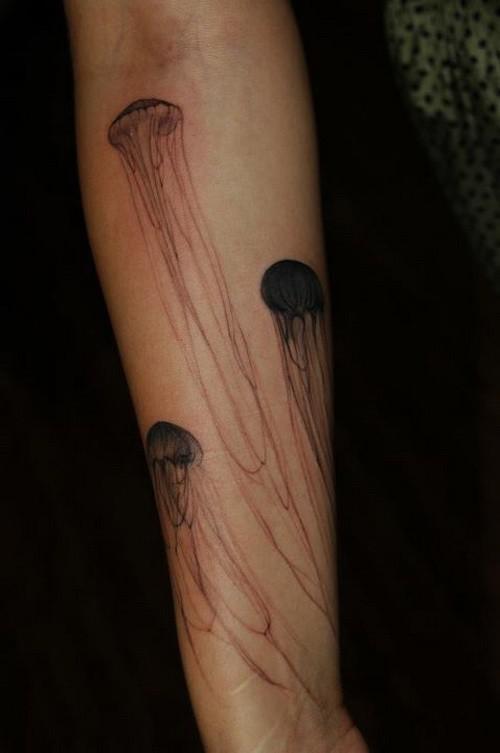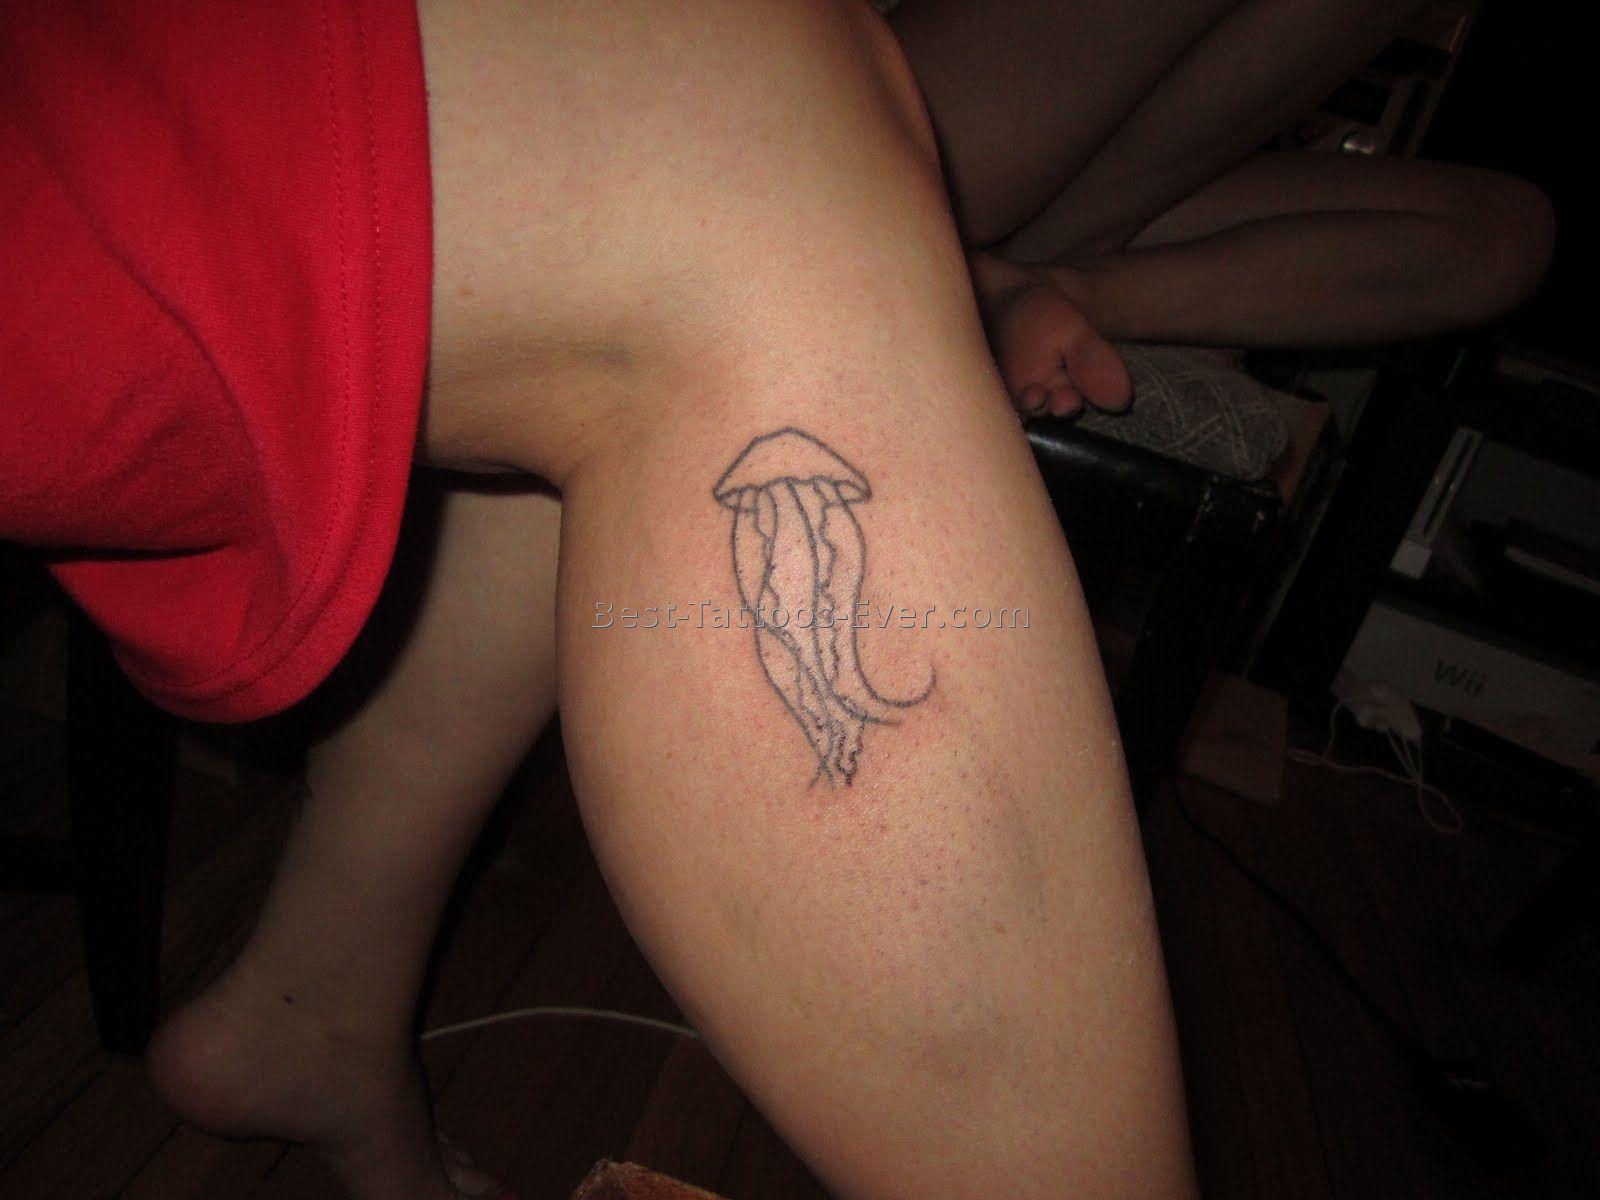The first image is the image on the left, the second image is the image on the right. Examine the images to the left and right. Is the description "Right and left images show a non-color tattoo of a single large jellyfish with trailing tentacles on a human leg." accurate? Answer yes or no. No. The first image is the image on the left, the second image is the image on the right. Considering the images on both sides, is "Each image shows exactly one tattoo on a person's bare skin, each image an elaborate jelly fish design with long tendrils inked in black." valid? Answer yes or no. No. 